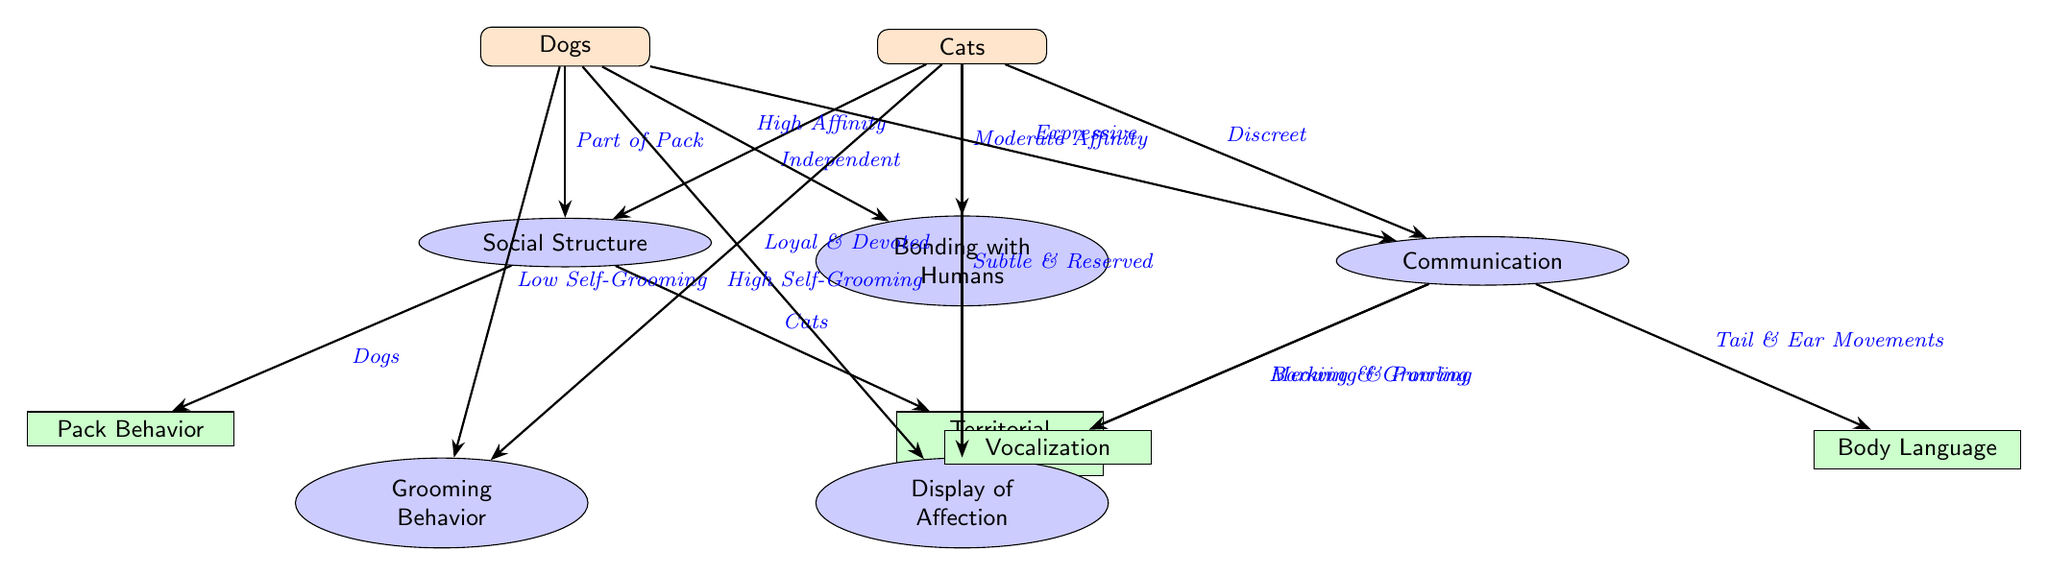What species is characterized by "Part of Pack"? The diagram shows that "Dogs" are described with the phrase "Part of Pack", indicating their social structure.
Answer: Dogs Which species has "High Self-Grooming"? According to the diagram, "Cats" are associated with "High Self-Grooming", which clearly identifies their grooming behavior.
Answer: Cats How many subcategories are listed under Communication? There are two subcategories under Communication: "Vocalization" and "Body Language". Therefore, the total count is two.
Answer: 2 What type of bonding do Dogs exhibit with humans? The diagram indicates that Dogs display "High Affinity" in their bonding with humans, showing a strong relationship characteristic.
Answer: High Affinity Which behavior is associated with Cats but not Dogs? "Territorial Behavior" is unique to Cats as it is explicitly linked in the diagram, while it is not mentioned for Dogs.
Answer: Territorial Behavior Why are Cats described as "Subtle & Reserved" in their display of affection? The diagram contrasts the affectionate behaviors between Cats and Dogs, indicating that Cats are "Subtle & Reserved" while Dogs are "Loyal & Devoted". This reasoning highlights the differing affection display characteristics.
Answer: Subtle & Reserved What is the communication style of Dogs as shown in the diagram? Dogs are categorized as "Expressive" in their communication style, which is illustrated under the Communication category.
Answer: Expressive What type of behavior do both Dogs and Cats exhibit when it comes to grooming? The diagram shows that Dogs have "Low Self-Grooming" while Cats have "High Self-Grooming", indicating differing grooming behaviors between the two species.
Answer: Low Self-Grooming (for Dogs), High Self-Grooming (for Cats) 